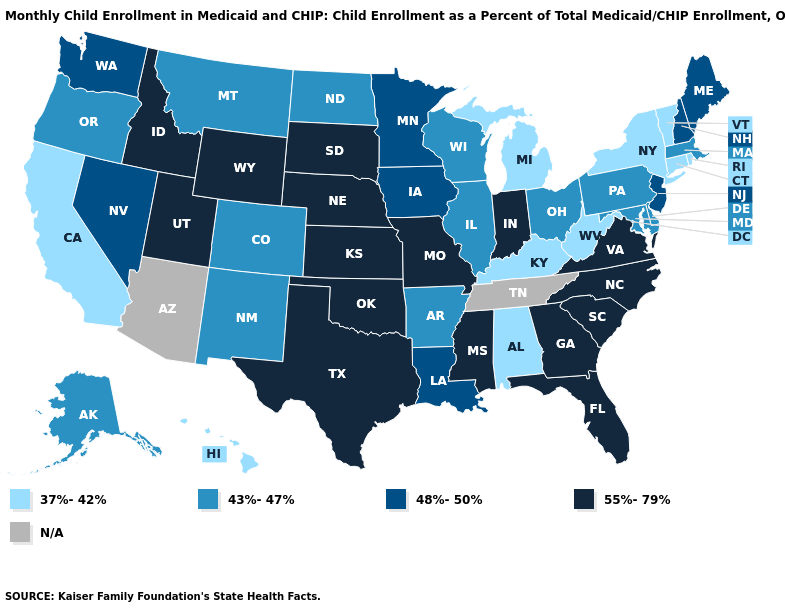Among the states that border Kentucky , does West Virginia have the lowest value?
Quick response, please. Yes. What is the lowest value in states that border Tennessee?
Short answer required. 37%-42%. What is the value of South Dakota?
Concise answer only. 55%-79%. Among the states that border Colorado , does New Mexico have the lowest value?
Give a very brief answer. Yes. Does the first symbol in the legend represent the smallest category?
Concise answer only. Yes. What is the value of New Mexico?
Concise answer only. 43%-47%. Name the states that have a value in the range 43%-47%?
Keep it brief. Alaska, Arkansas, Colorado, Delaware, Illinois, Maryland, Massachusetts, Montana, New Mexico, North Dakota, Ohio, Oregon, Pennsylvania, Wisconsin. What is the value of Nevada?
Concise answer only. 48%-50%. What is the value of Massachusetts?
Concise answer only. 43%-47%. How many symbols are there in the legend?
Give a very brief answer. 5. What is the lowest value in the USA?
Give a very brief answer. 37%-42%. Among the states that border Oklahoma , which have the lowest value?
Short answer required. Arkansas, Colorado, New Mexico. Among the states that border Colorado , does New Mexico have the highest value?
Keep it brief. No. 